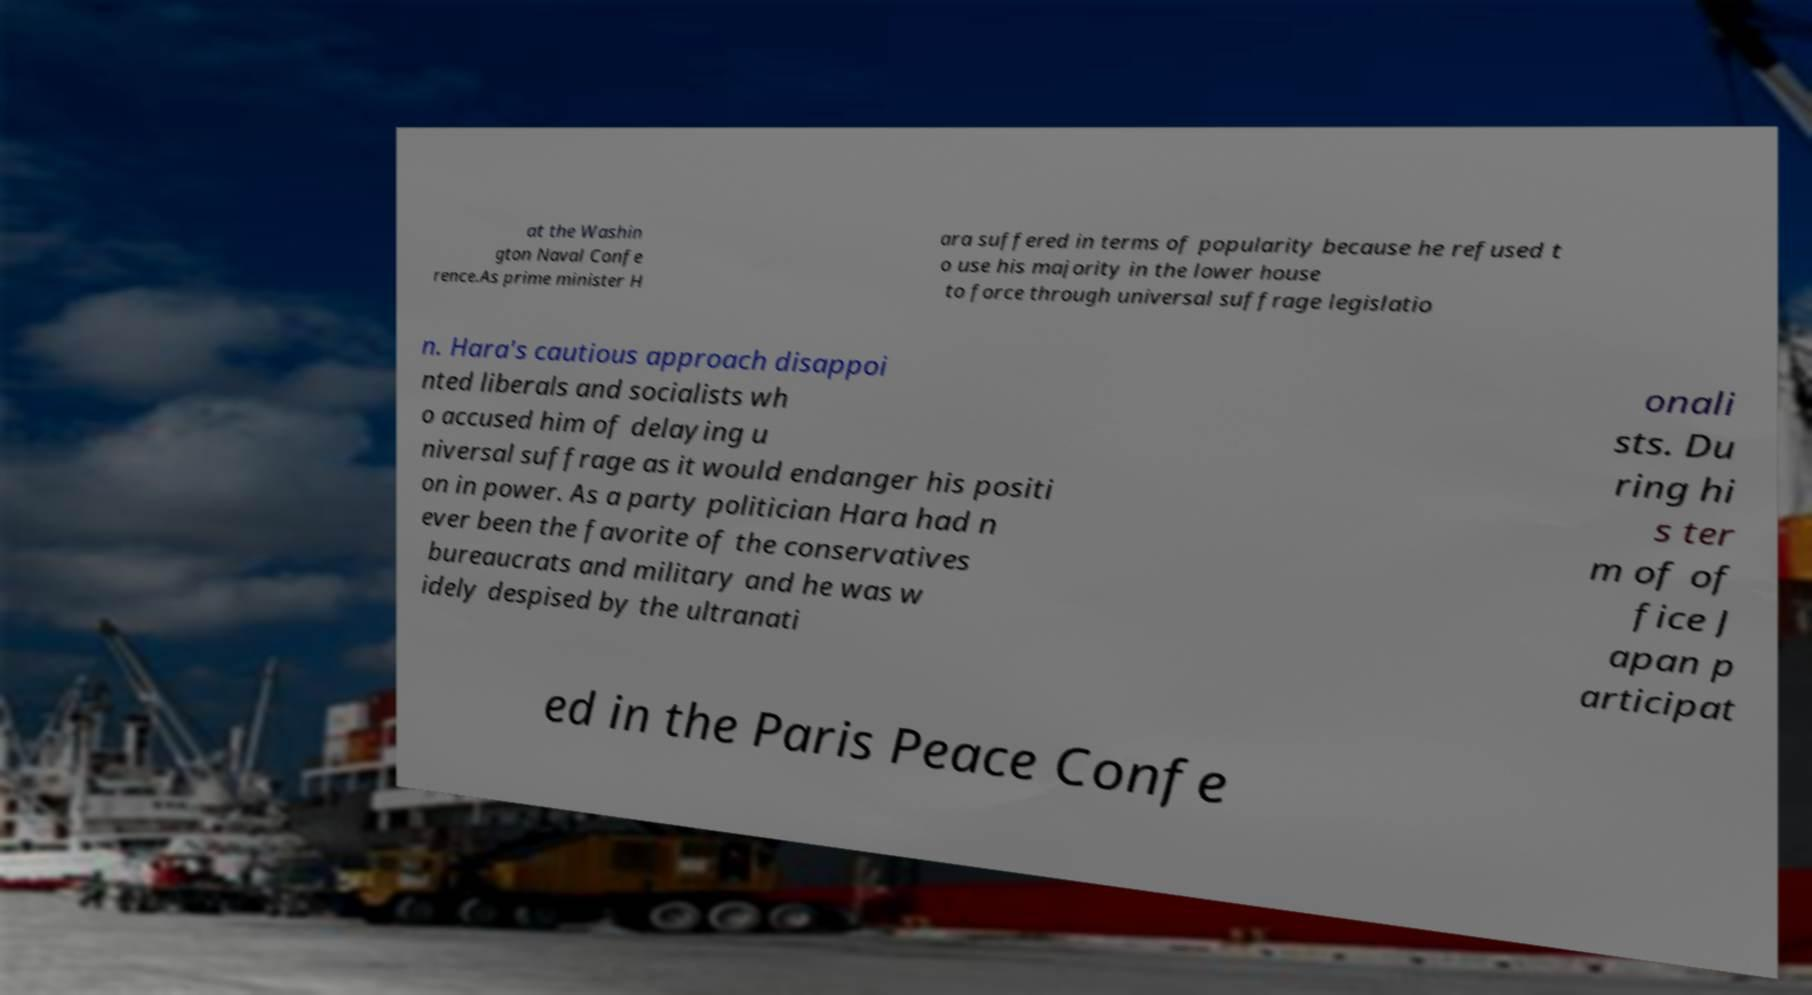Could you extract and type out the text from this image? at the Washin gton Naval Confe rence.As prime minister H ara suffered in terms of popularity because he refused t o use his majority in the lower house to force through universal suffrage legislatio n. Hara's cautious approach disappoi nted liberals and socialists wh o accused him of delaying u niversal suffrage as it would endanger his positi on in power. As a party politician Hara had n ever been the favorite of the conservatives bureaucrats and military and he was w idely despised by the ultranati onali sts. Du ring hi s ter m of of fice J apan p articipat ed in the Paris Peace Confe 